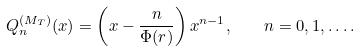Convert formula to latex. <formula><loc_0><loc_0><loc_500><loc_500>Q _ { n } ^ { ( M _ { T } ) } ( x ) = \left ( x - \frac { n } { \Phi ( r ) } \right ) x ^ { n - 1 } , \quad n = 0 , 1 , \dots .</formula> 